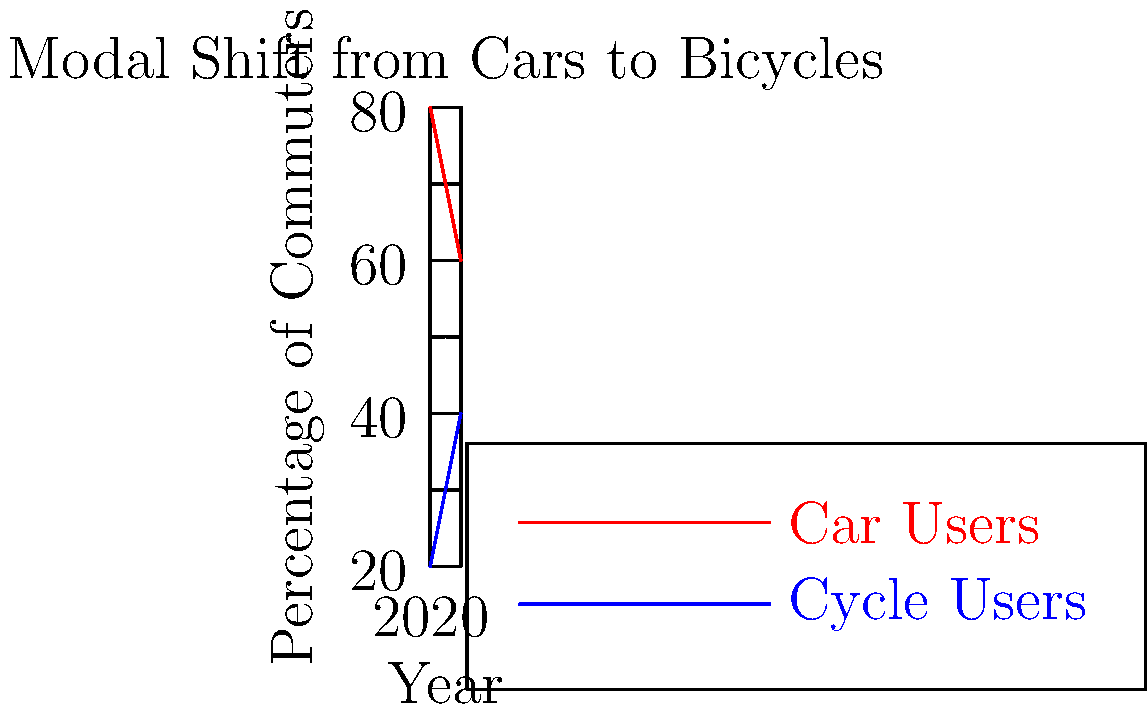Based on the modal shift graph, if the average car commute in the city produces 2.5 kg of CO₂ per day and the average bicycle commute produces 0 kg, calculate the total reduction in daily CO₂ emissions (in kg) from 2020 to 2024, assuming a constant total of 100,000 commuters. To solve this problem, we'll follow these steps:

1. Calculate the change in the number of car commuters from 2020 to 2024:
   * In 2020: 80% of 100,000 = 80,000 car commuters
   * In 2024: 60% of 100,000 = 60,000 car commuters
   * Decrease in car commuters: 80,000 - 60,000 = 20,000

2. Calculate the daily CO₂ emissions reduction:
   * Each car commuter switching to cycling reduces emissions by 2.5 kg CO₂ per day
   * Total daily reduction: 20,000 × 2.5 kg = 50,000 kg CO₂

Therefore, the total reduction in daily CO₂ emissions from 2020 to 2024 is 50,000 kg.
Answer: 50,000 kg CO₂ 